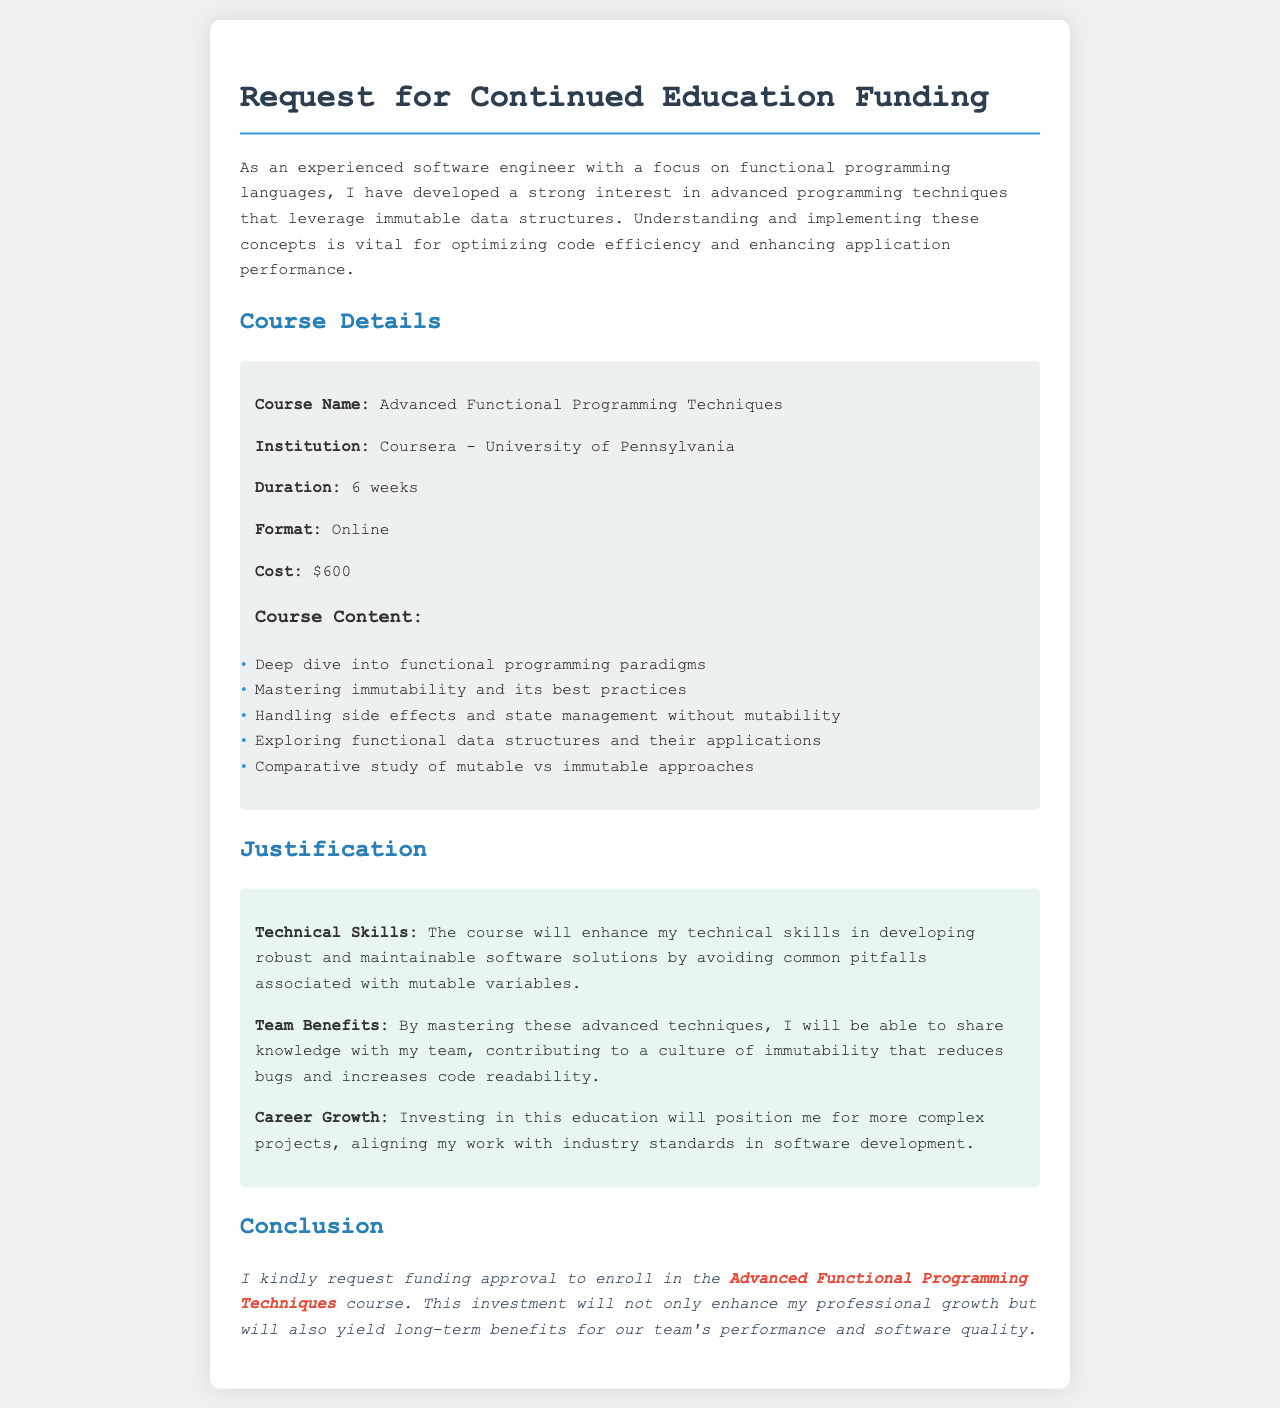What is the course name? The course name is mentioned in the course details section of the document.
Answer: Advanced Functional Programming Techniques Who is offering the course? The institution offering the course is listed under course details.
Answer: Coursera - University of Pennsylvania What is the cost of the course? The cost is specified in the course details section.
Answer: $600 How long is the course duration? The duration is mentioned in the course details part of the document.
Answer: 6 weeks What is a key focus of the course content? A key focus can be determined from the list of items in the course content section.
Answer: Mastering immutability and its best practices What benefit does the writer mention for the team? This benefit is found in the justification section discussing team advantages.
Answer: Contributing to a culture of immutability What is the writer requesting in the conclusion? The conclusion states the specific request made by the writer in the document.
Answer: Funding approval What effect is the education expected to have on the writer’s career? This is discussed in the justification section related to career growth.
Answer: Position me for more complex projects What is the emphasis of the writer's interest? The introduction highlights the writer’s main area of interest in the document.
Answer: Advanced programming techniques that leverage immutable data structures 